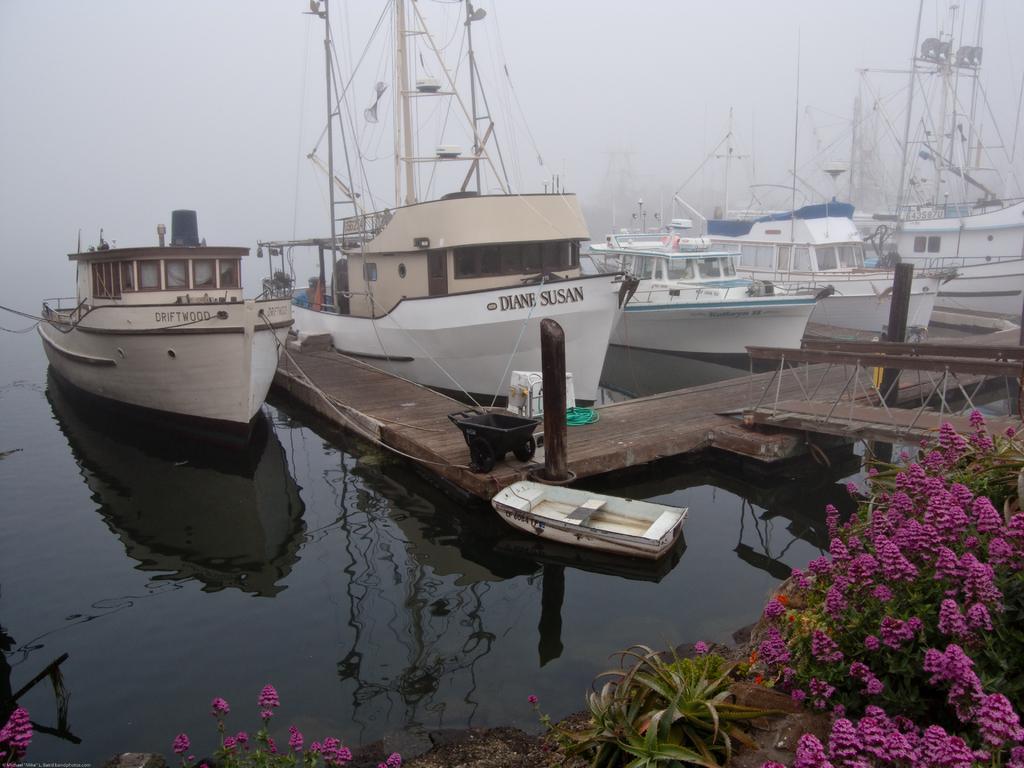How would you summarize this image in a sentence or two? In this image there is water and we can see boats on the water. There is a board bridge. At the bottom there are plants and we can see flowers. In the background there is sky. 